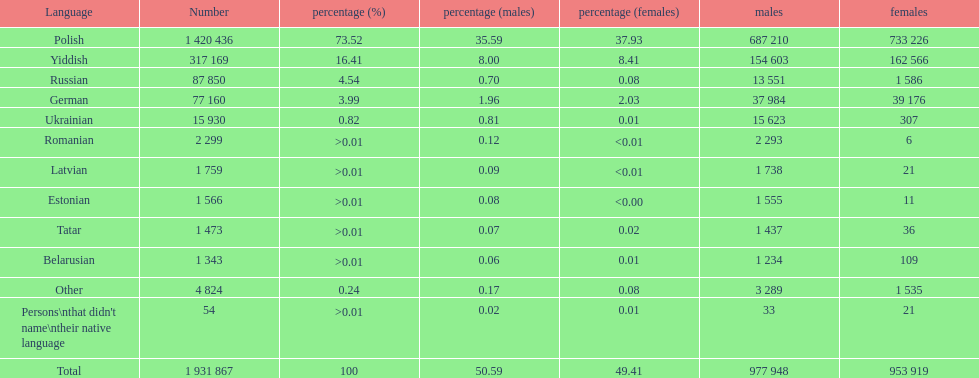Which language had the smallest number of females speaking it. Romanian. 